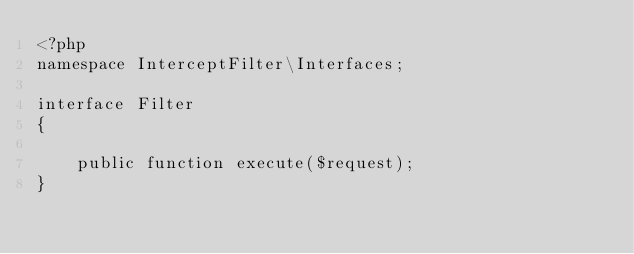Convert code to text. <code><loc_0><loc_0><loc_500><loc_500><_PHP_><?php
namespace InterceptFilter\Interfaces;

interface Filter
{

    public function execute($request);
}</code> 